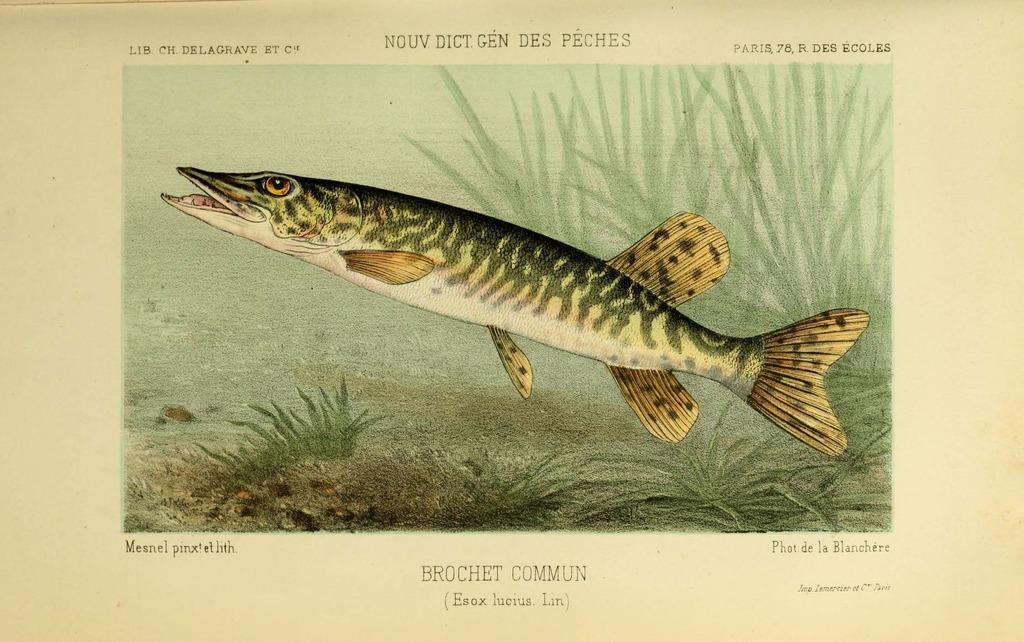What is the main subject of the picture in the image? There is a picture of a fish in the image. What other images are present on the paper? There are pictures of plants on the paper. What can be seen at the top of the paper? There is text at the top of the paper. What is located at the bottom of the paper? There is text at the bottom of the paper. What type of pipe is being used by the fish in the image? There is no pipe present in the image; it features a picture of a fish and pictures of plants on a paper with text at the top and bottom. 